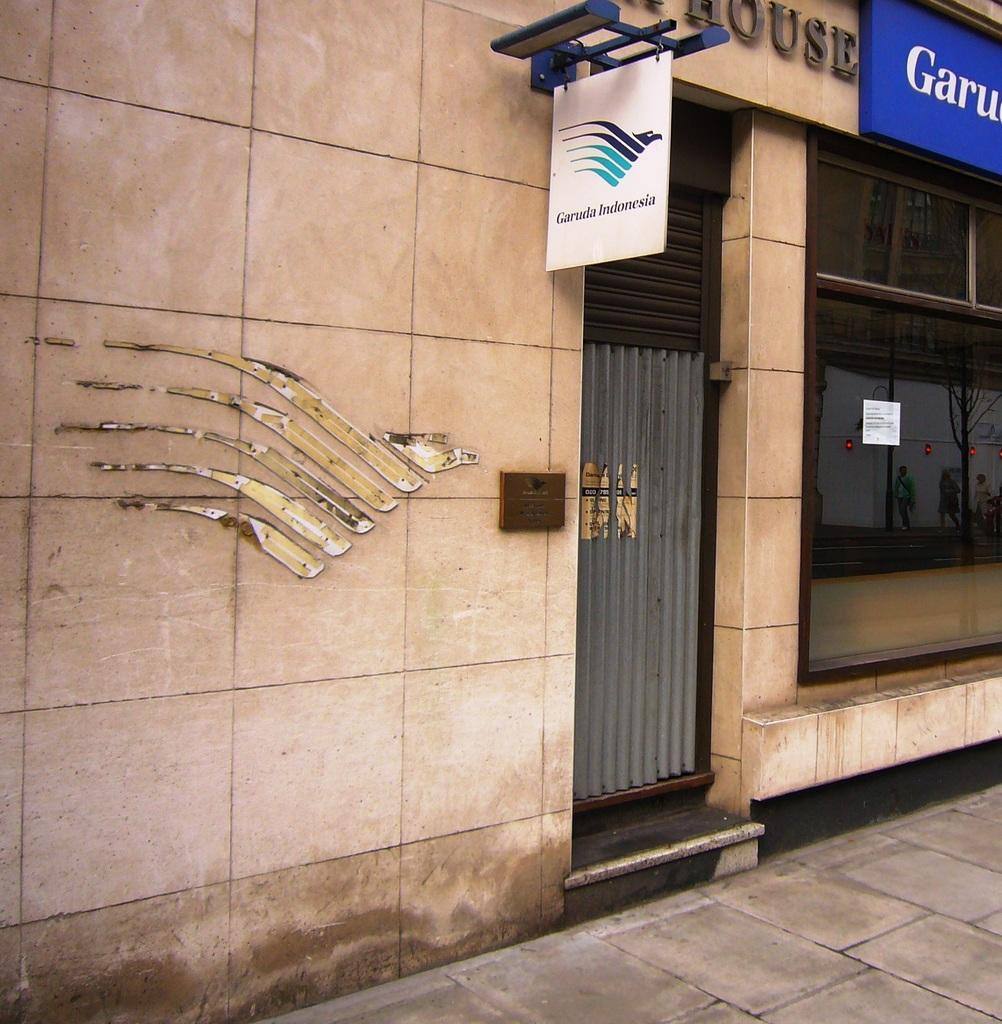What type of structures can be seen in the image? There are buildings in the image. What else is present on the buildings or nearby? There is a poster and a gate in the image. What type of trousers can be seen hanging on the gate in the image? There are no trousers present in the image; the gate is not associated with any clothing items. 